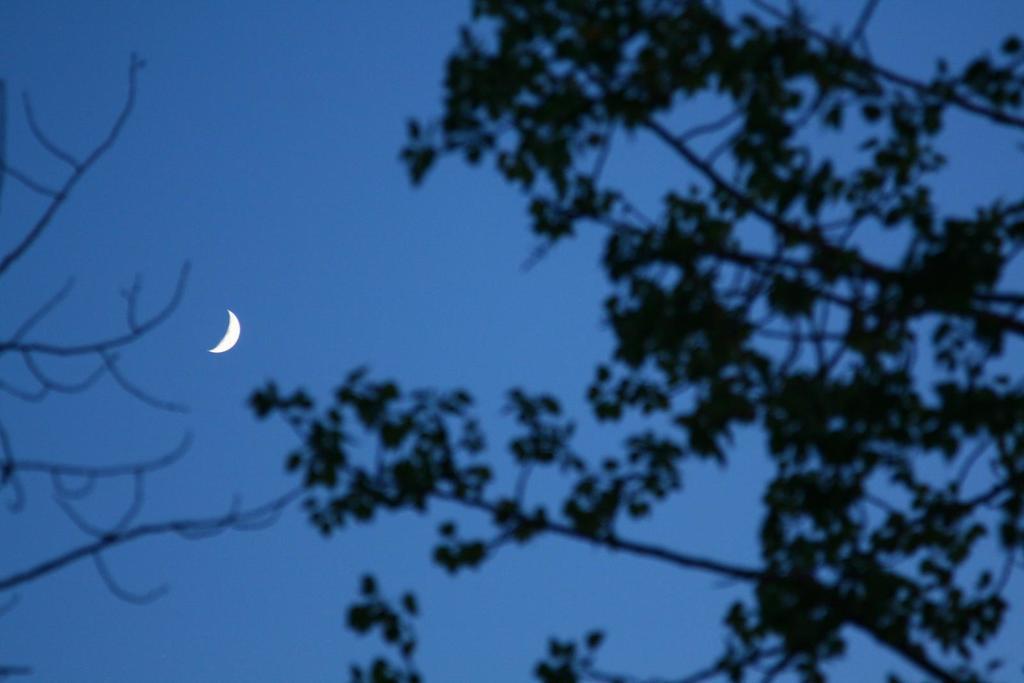Could you give a brief overview of what you see in this image? In the foreground of the picture there are branches of a tree. In the center of the picture it is moon in the sky. 